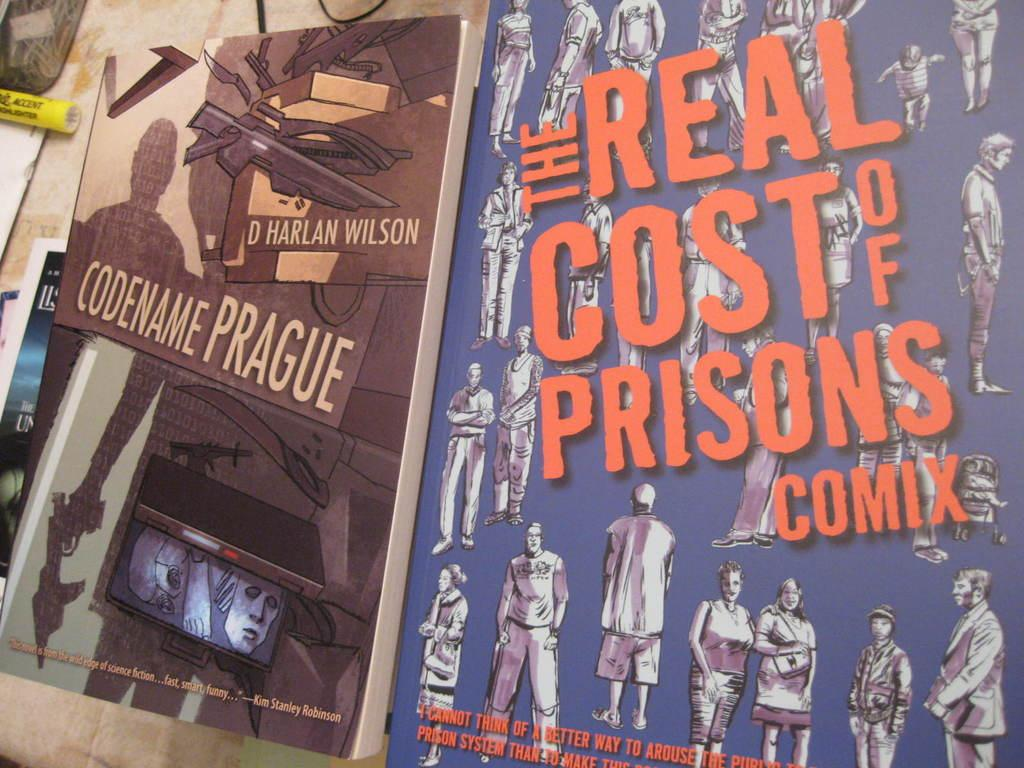<image>
Summarize the visual content of the image. A poster with illustrations of people is advertising The Real Cost of Prisons Comix. 